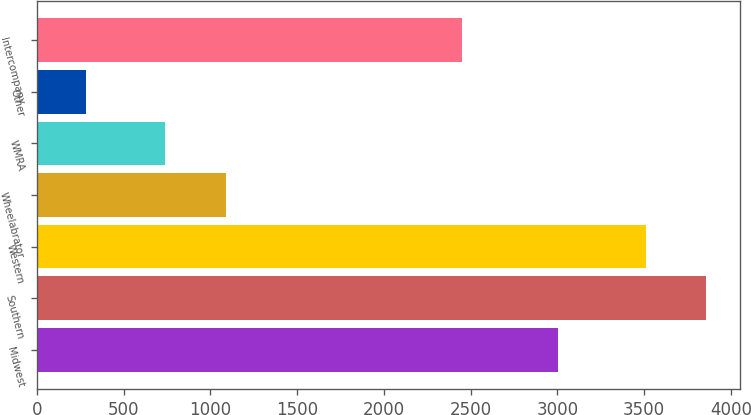Convert chart to OTSL. <chart><loc_0><loc_0><loc_500><loc_500><bar_chart><fcel>Midwest<fcel>Southern<fcel>Western<fcel>Wheelabrator<fcel>WMRA<fcel>Other<fcel>Intercompany<nl><fcel>3003<fcel>3858.6<fcel>3511<fcel>1087.6<fcel>740<fcel>283<fcel>2449<nl></chart> 